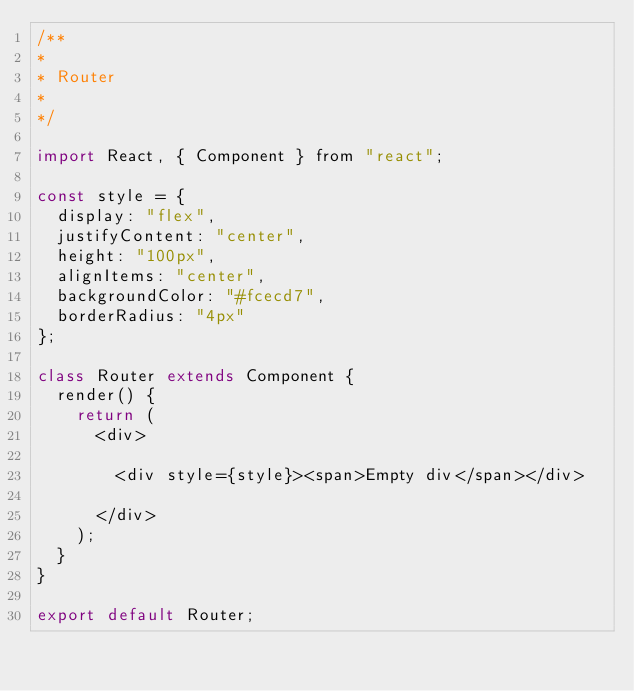Convert code to text. <code><loc_0><loc_0><loc_500><loc_500><_JavaScript_>/**
*
* Router
*
*/

import React, { Component } from "react";

const style = {
  display: "flex",
  justifyContent: "center",
  height: "100px",
  alignItems: "center",
  backgroundColor: "#fcecd7",
  borderRadius: "4px"
};

class Router extends Component {
  render() {
    return (
      <div>

        <div style={style}><span>Empty div</span></div>

      </div>
    );
  }
}

export default Router;
</code> 